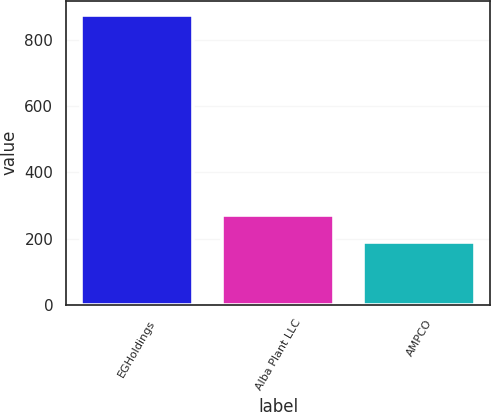Convert chart. <chart><loc_0><loc_0><loc_500><loc_500><bar_chart><fcel>EGHoldings<fcel>Alba Plant LLC<fcel>AMPCO<nl><fcel>875<fcel>272<fcel>191<nl></chart> 